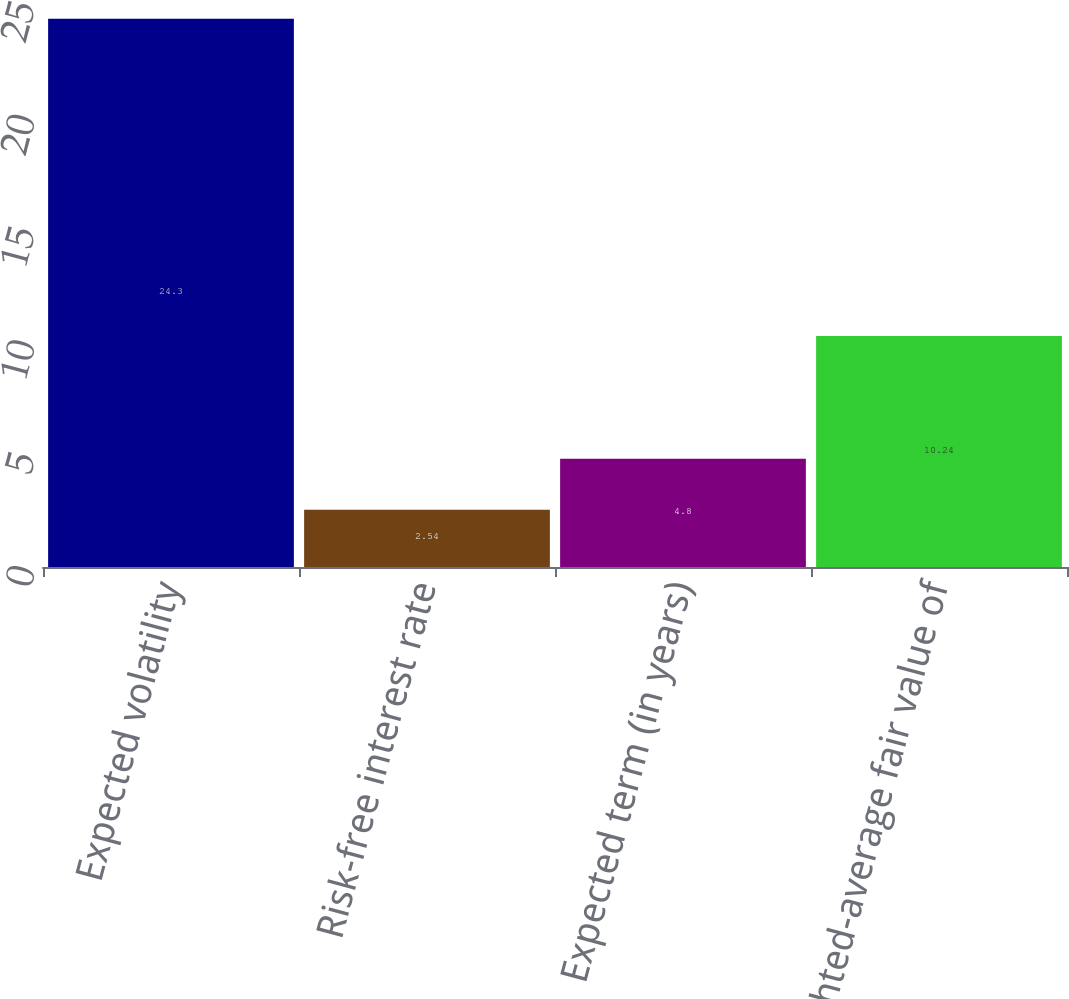<chart> <loc_0><loc_0><loc_500><loc_500><bar_chart><fcel>Expected volatility<fcel>Risk-free interest rate<fcel>Expected term (in years)<fcel>Weighted-average fair value of<nl><fcel>24.3<fcel>2.54<fcel>4.8<fcel>10.24<nl></chart> 